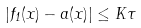<formula> <loc_0><loc_0><loc_500><loc_500>| f _ { 1 } ( x ) - a ( x ) | \leq K \tau</formula> 